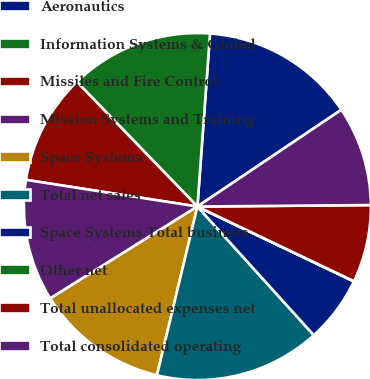<chart> <loc_0><loc_0><loc_500><loc_500><pie_chart><fcel>Aeronautics<fcel>Information Systems & Global<fcel>Missiles and Fire Control<fcel>Mission Systems and Training<fcel>Space Systems<fcel>Total net sales<fcel>Space Systems Total business<fcel>Other net<fcel>Total unallocated expenses net<fcel>Total consolidated operating<nl><fcel>14.42%<fcel>13.39%<fcel>10.31%<fcel>11.34%<fcel>12.37%<fcel>15.45%<fcel>6.19%<fcel>0.02%<fcel>7.22%<fcel>9.28%<nl></chart> 